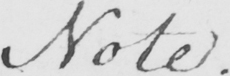What is written in this line of handwriting? Note . 